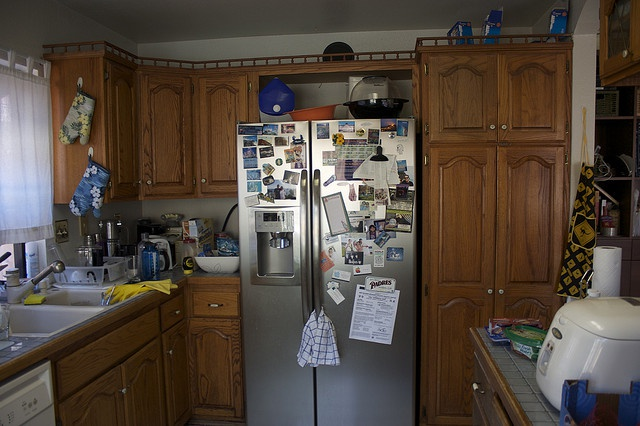Describe the objects in this image and their specific colors. I can see refrigerator in black, gray, darkgray, and lightgray tones, oven in black, darkgray, and gray tones, sink in black and gray tones, sink in black, gray, and olive tones, and bowl in black, gray, and darkgray tones in this image. 